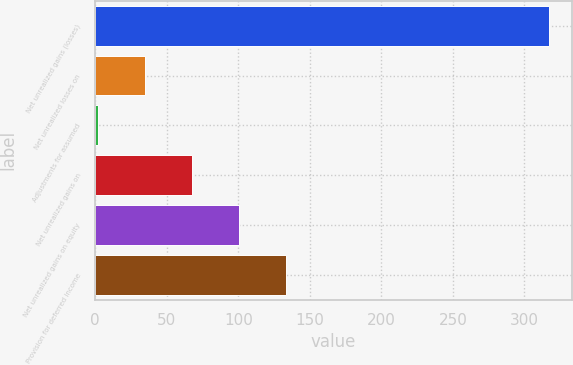<chart> <loc_0><loc_0><loc_500><loc_500><bar_chart><fcel>Net unrealized gains (losses)<fcel>Net unrealized losses on<fcel>Adjustments for assumed<fcel>Net unrealized gains on<fcel>Net unrealized gains on equity<fcel>Provision for deferred income<nl><fcel>317.1<fcel>34.95<fcel>2.2<fcel>67.7<fcel>100.45<fcel>133.2<nl></chart> 